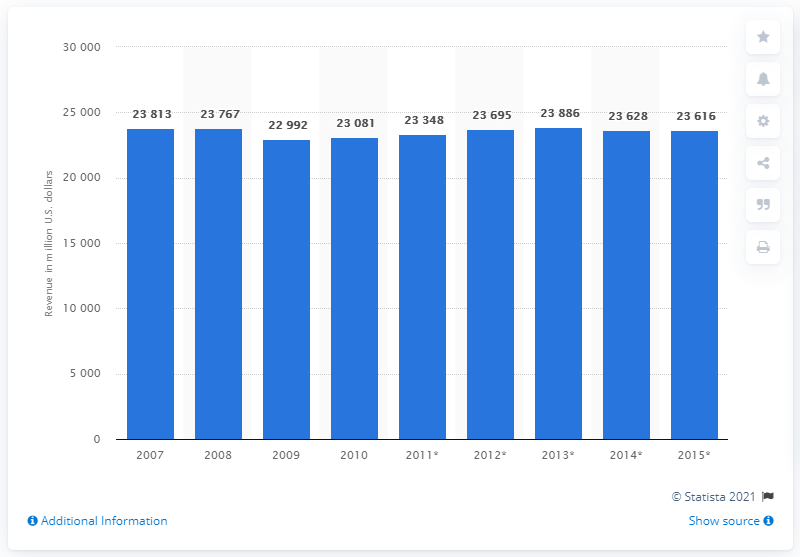List a handful of essential elements in this visual. The estimated revenue from printer cartridges in the United States in 2012 was approximately 23,616. 